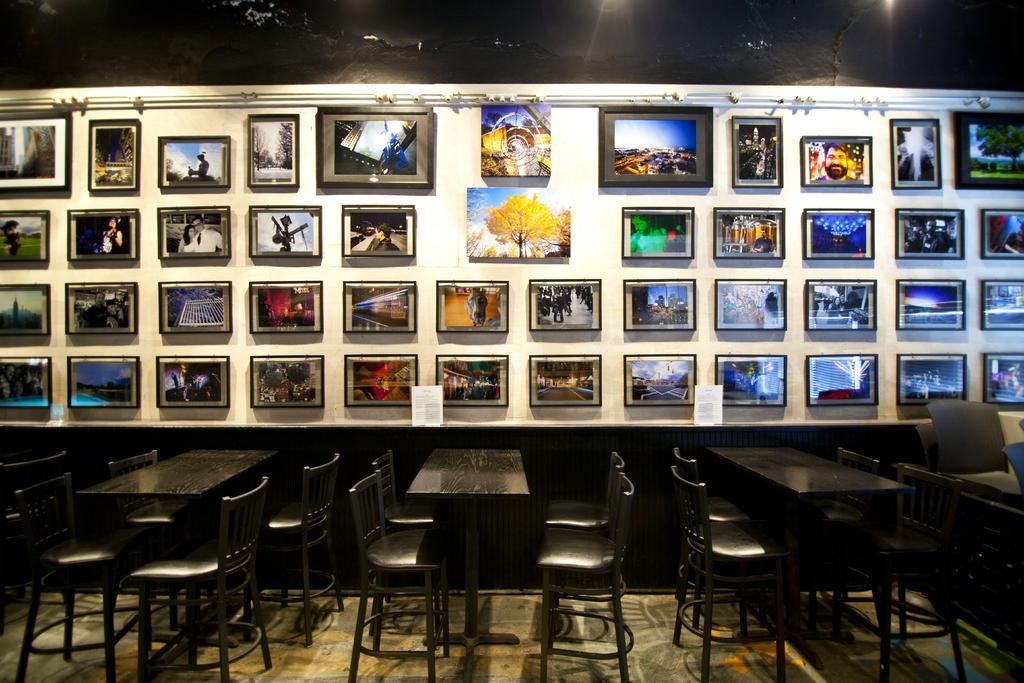In one or two sentences, can you explain what this image depicts? In this picture we can see tables and chairs on the floor, frames on the wall, cards and some objects. 